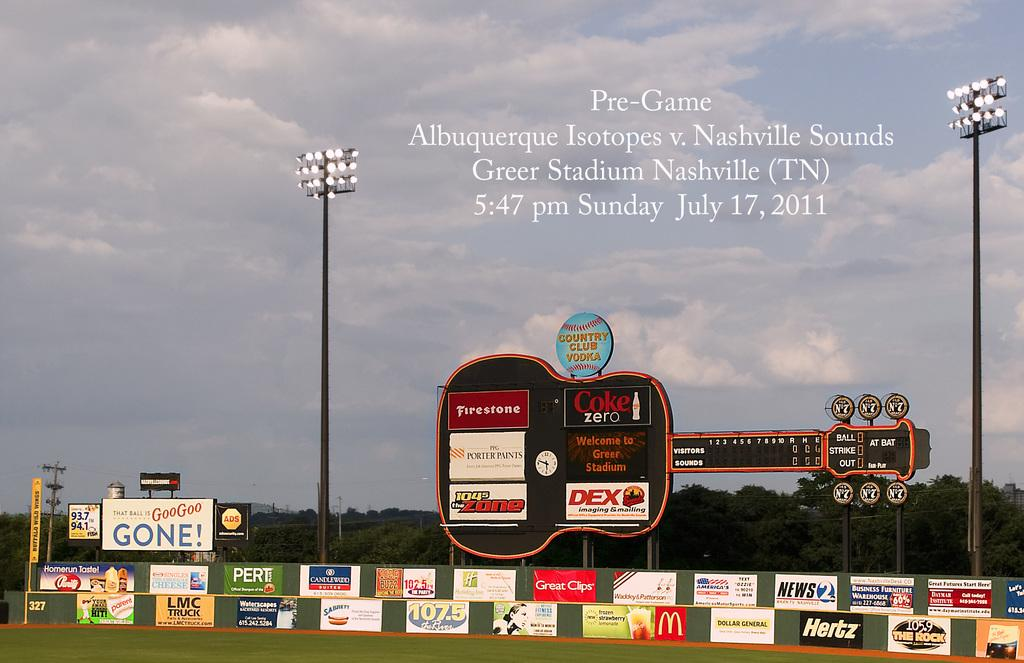<image>
Describe the image concisely. The outer wall of a baseball stadium featuring several signs for mcdonalds, coca cola and other brands. 